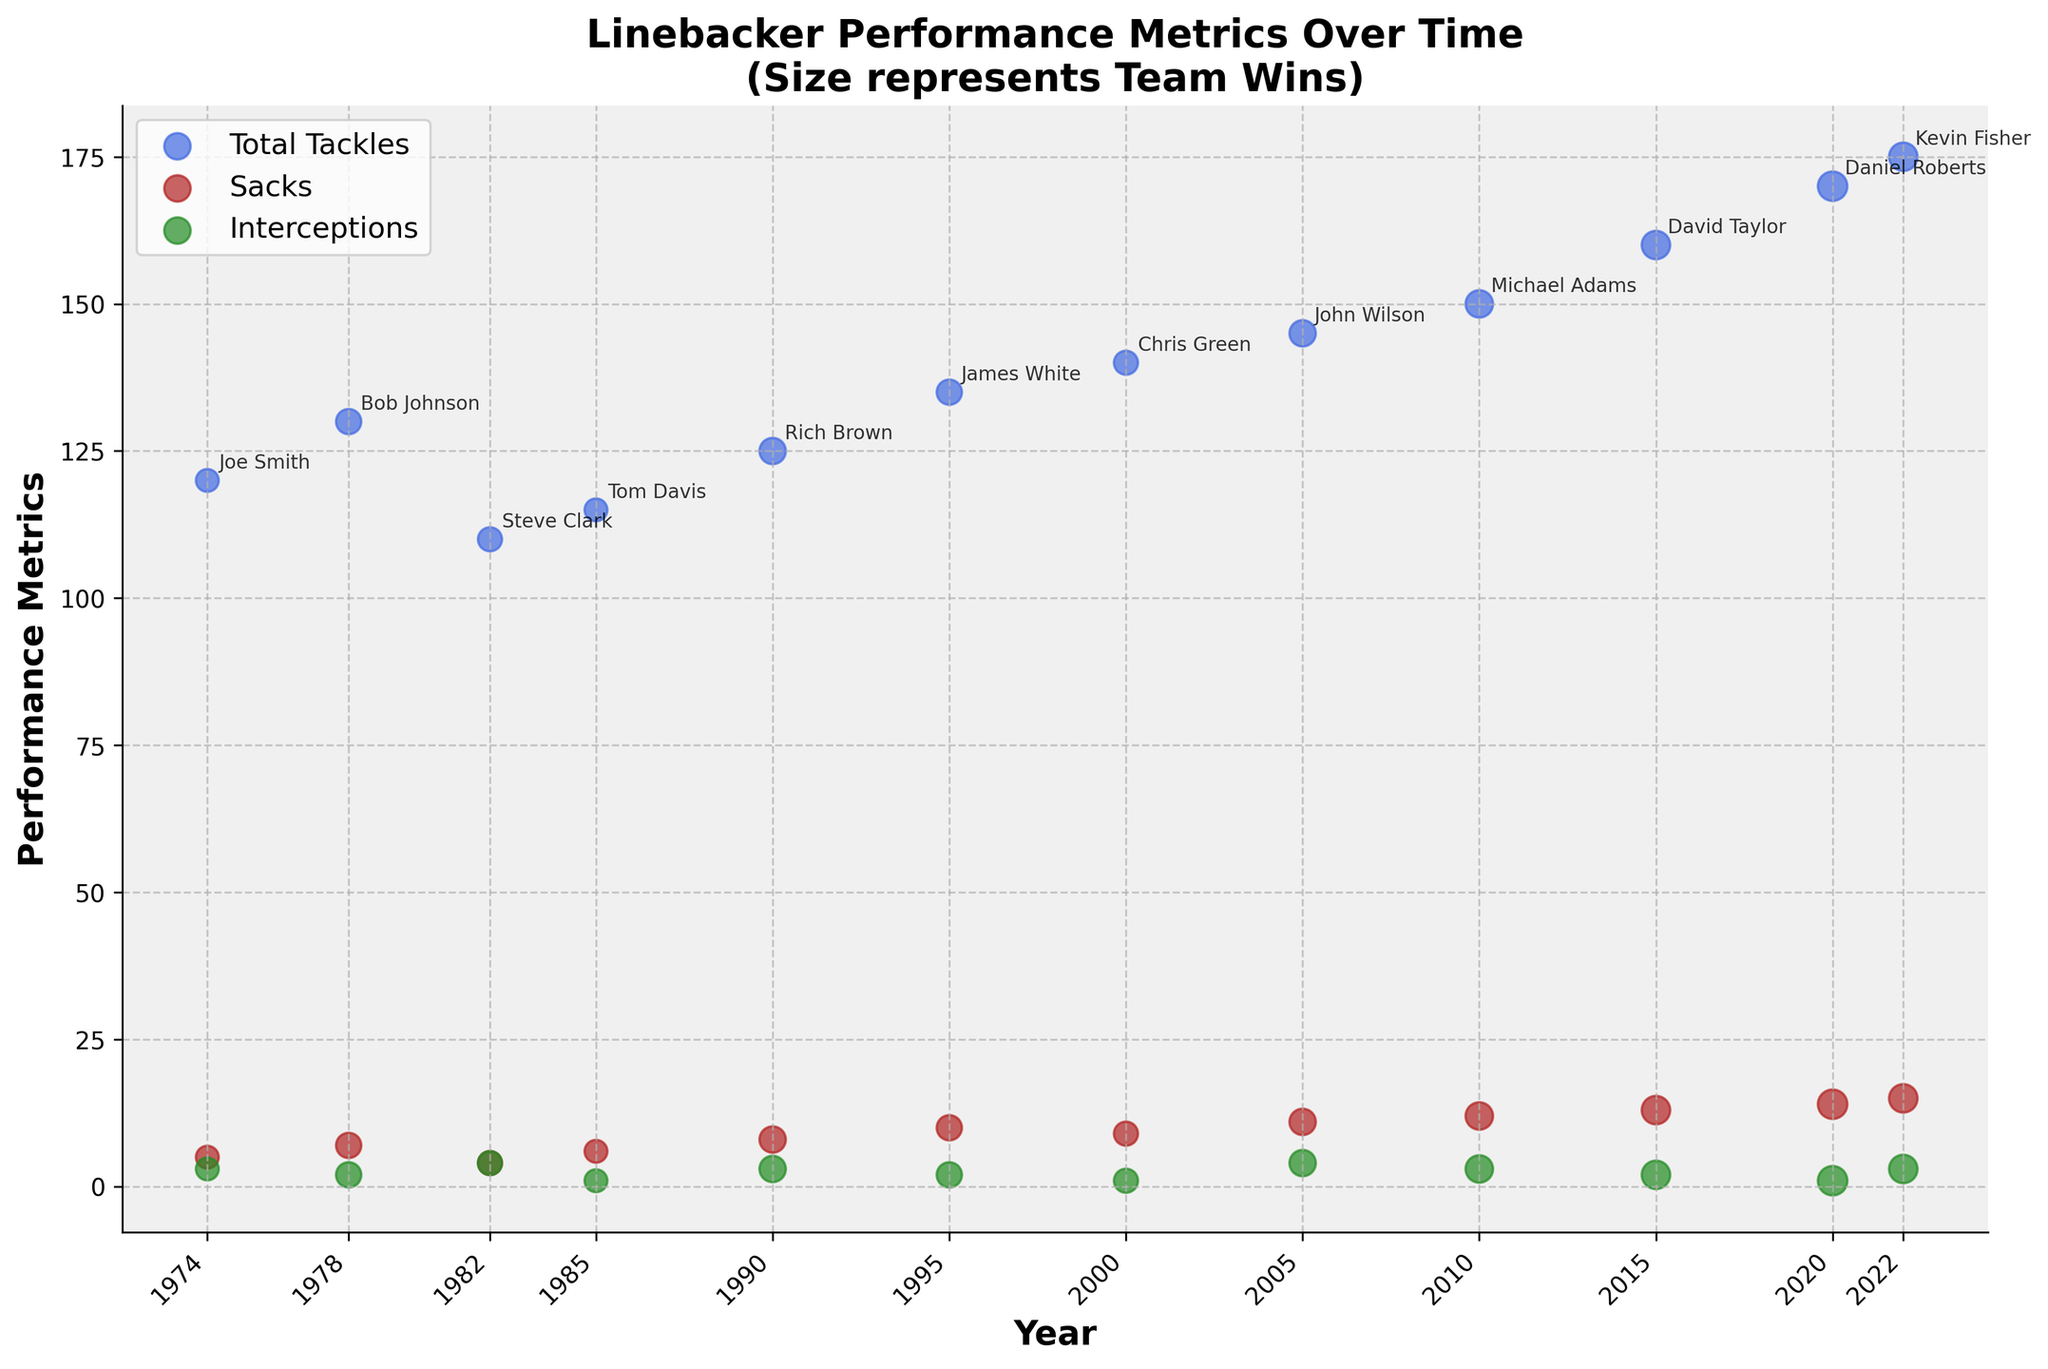What's the title of the plot? The title of the plot is typically found at the top and it gives an overview of what the figure represents. Here it's explicitly stated.
Answer: Linebacker Performance Metrics Over Time (Size represents Team Wins) How many players from the 1970s are represented in the plot? Looking at the x-axis labeled 'Year', we see marks and data points corresponding to the 1970s. These are two distinct years: 1974 and 1978.
Answer: 2 What is the trend of total tackles from 1974 to 2022? Observing the scatter points for total tackles (in royal blue), they increase gradually over time with each decade showing a higher value.
Answer: Increasing Which player had the highest number of team wins? Comparing the size of the scatter points (each player's statistics), larger sizes denote more team wins. The largest point is associated with Daniel Roberts in 2020.
Answer: Daniel Roberts What is the relationship between team wins and tackles in 2015? The size of the scatter point for tackles in 2015 shows 14 team wins, and the total tackles are 160.
Answer: 14 team wins, 160 tackles Which player had the most sacks, and in what year? Among the firebrick-colored points, the highest value on the y-axis represents the most sacks. This point is at the year 2022, for Kevin Fisher.
Answer: Kevin Fisher, 2022 Compare the total tackles in 1995 and 2005. Which year had more, and by how much? Looking at the scatter points for tackles in both years, 2005 (John Wilson: 145) had more than 1995 (James White: 135). The difference is 145 - 135.
Answer: 2005, by 10 Did the number of interceptions by linebackers show a noticeable trend over the years? Examining the forest green points representing interceptions, they show no significant increasing or decreasing trend over the timeframe; values fluctuate without a clear pattern.
Answer: No noticeable trend Which player had the lowest number of interceptions, and in which year did this occur? The smallest value among the interceptions (forest green points) indicates the lowest number. This occurred in 2020 for Daniel Roberts, who had 1 interception.
Answer: Daniel Roberts, 2020 Compare the performance of linebackers in terms of sacks in 2000 and 2010. Which year had more sacks, and by how much? The scatter points for sacks in the years 2000 and 2010 need to be checked. Chris Green in 2000 (9 sacks) had fewer than Michael Adams in 2010 (12 sacks). The difference is 12 - 9.
Answer: 2010, by 3 